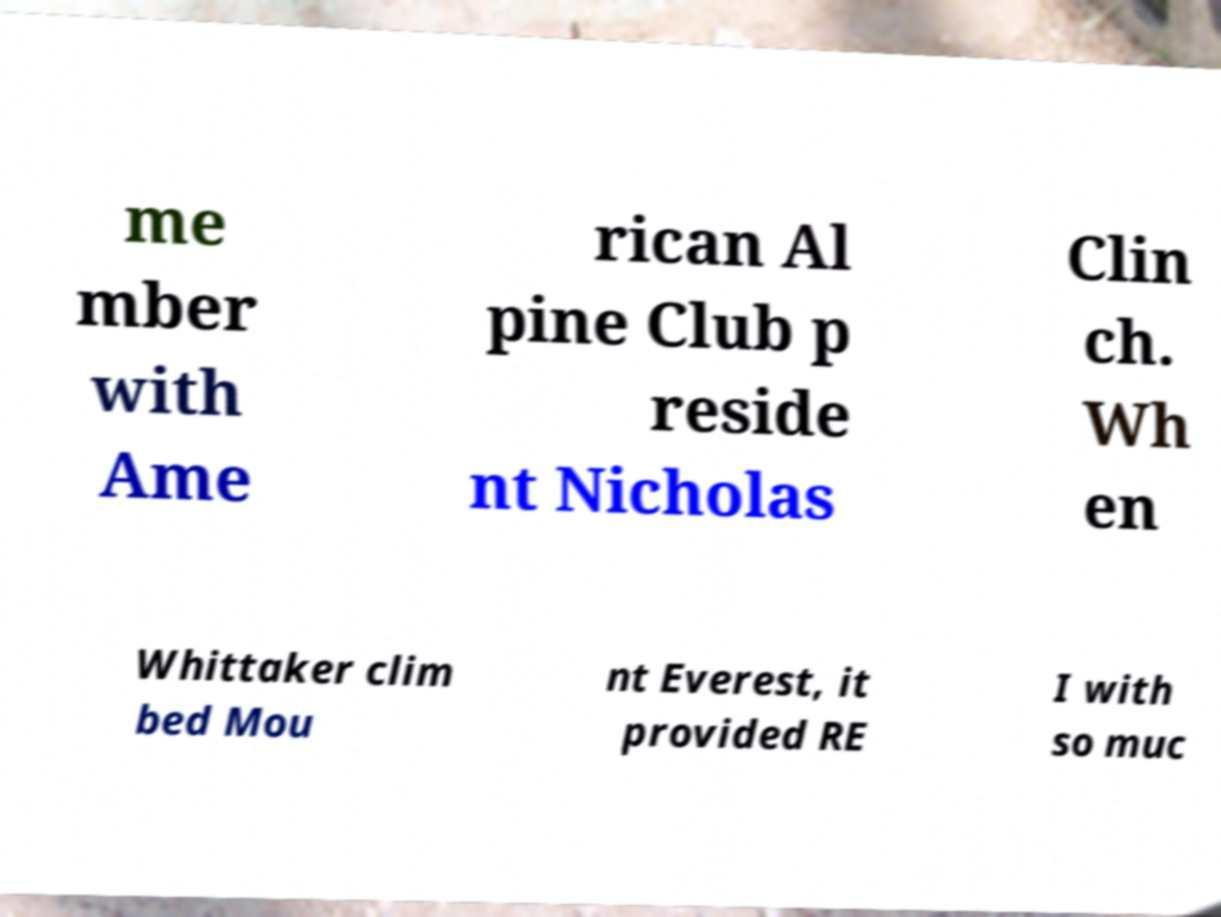For documentation purposes, I need the text within this image transcribed. Could you provide that? me mber with Ame rican Al pine Club p reside nt Nicholas Clin ch. Wh en Whittaker clim bed Mou nt Everest, it provided RE I with so muc 